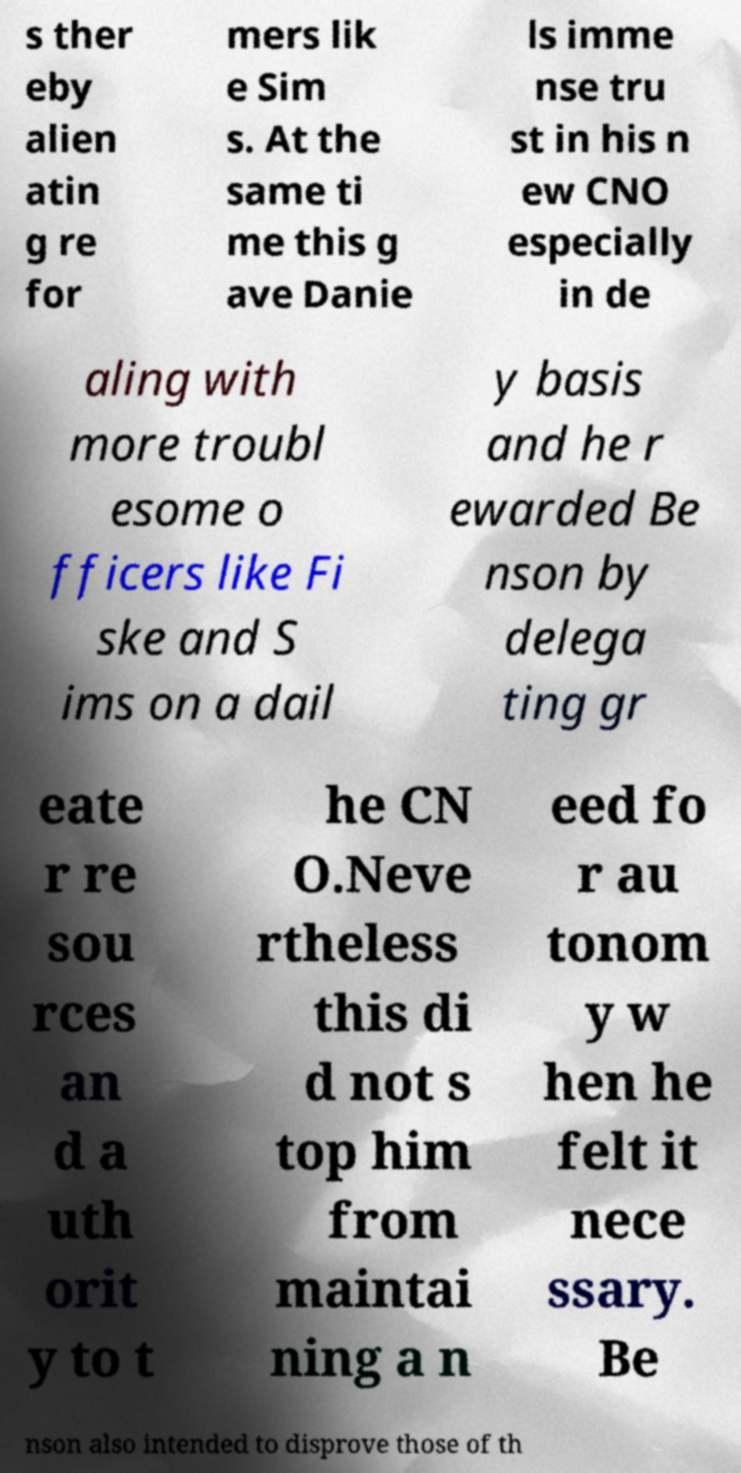I need the written content from this picture converted into text. Can you do that? s ther eby alien atin g re for mers lik e Sim s. At the same ti me this g ave Danie ls imme nse tru st in his n ew CNO especially in de aling with more troubl esome o fficers like Fi ske and S ims on a dail y basis and he r ewarded Be nson by delega ting gr eate r re sou rces an d a uth orit y to t he CN O.Neve rtheless this di d not s top him from maintai ning a n eed fo r au tonom y w hen he felt it nece ssary. Be nson also intended to disprove those of th 